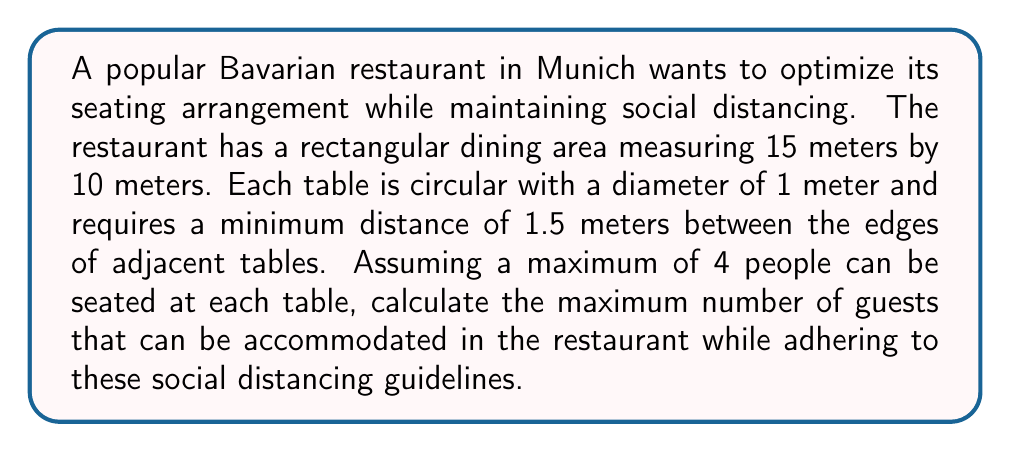Could you help me with this problem? Let's approach this problem step by step:

1. First, we need to determine the effective space each table occupies, including the social distancing area:
   - Table diameter: 1 m
   - Required distance between table edges: 1.5 m
   - Total diameter of space per table: 1 m + 2 * 1.5 m = 4 m

2. We can model this as a grid problem, where each table occupies a 4m x 4m square in the grid.

3. Calculate the number of tables that can fit along each dimension:
   - Length: $\lfloor \frac{15}{4} \rfloor = 3$ tables
   - Width: $\lfloor \frac{10}{4} \rfloor = 2$ tables

4. Total number of tables:
   $3 \times 2 = 6$ tables

5. To visualize this arrangement:

[asy]
unitsize(10mm);
for(int i=0; i<4; ++i) {
  draw((0,i*4)--(15,i*4),gray);
}
for(int i=0; i<5; ++i) {
  draw((i*4,0)--(i*4,10),gray);
}
for(int i=0; i<3; ++i) {
  for(int j=0; j<2; ++j) {
    draw(circle((2+i*4,2+j*4),0.5),blue);
  }
}
draw((0,0)--(15,0)--(15,10)--(0,10)--cycle);
label("15m",(7.5,-0.5));
label("10m",(-0.5,5),W);
[/asy]

6. Each table can seat a maximum of 4 people.

7. Maximum number of guests:
   $6 \text{ tables} \times 4 \text{ guests/table} = 24 \text{ guests}$

Therefore, the restaurant can accommodate a maximum of 24 guests while maintaining the required social distancing measures.
Answer: The maximum number of guests that can be accommodated is 24. 